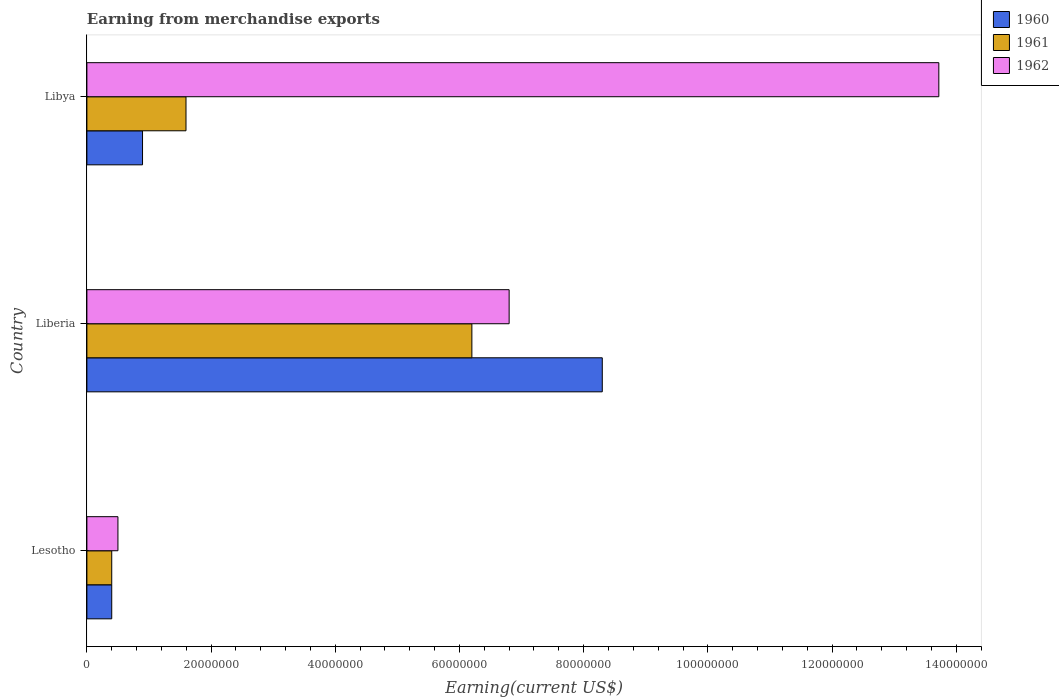How many different coloured bars are there?
Make the answer very short. 3. How many groups of bars are there?
Provide a succinct answer. 3. Are the number of bars per tick equal to the number of legend labels?
Give a very brief answer. Yes. How many bars are there on the 2nd tick from the bottom?
Keep it short and to the point. 3. What is the label of the 1st group of bars from the top?
Provide a short and direct response. Libya. In how many cases, is the number of bars for a given country not equal to the number of legend labels?
Give a very brief answer. 0. What is the amount earned from merchandise exports in 1962 in Libya?
Provide a short and direct response. 1.37e+08. Across all countries, what is the maximum amount earned from merchandise exports in 1961?
Provide a short and direct response. 6.20e+07. In which country was the amount earned from merchandise exports in 1961 maximum?
Make the answer very short. Liberia. In which country was the amount earned from merchandise exports in 1962 minimum?
Provide a succinct answer. Lesotho. What is the total amount earned from merchandise exports in 1961 in the graph?
Keep it short and to the point. 8.20e+07. What is the difference between the amount earned from merchandise exports in 1960 in Lesotho and that in Liberia?
Ensure brevity in your answer.  -7.90e+07. What is the difference between the amount earned from merchandise exports in 1960 in Liberia and the amount earned from merchandise exports in 1962 in Libya?
Give a very brief answer. -5.42e+07. What is the average amount earned from merchandise exports in 1962 per country?
Your response must be concise. 7.01e+07. What is the difference between the amount earned from merchandise exports in 1962 and amount earned from merchandise exports in 1960 in Libya?
Your answer should be compact. 1.28e+08. In how many countries, is the amount earned from merchandise exports in 1960 greater than 24000000 US$?
Your answer should be very brief. 1. What is the ratio of the amount earned from merchandise exports in 1962 in Lesotho to that in Libya?
Make the answer very short. 0.04. What is the difference between the highest and the second highest amount earned from merchandise exports in 1960?
Ensure brevity in your answer.  7.40e+07. What is the difference between the highest and the lowest amount earned from merchandise exports in 1962?
Your answer should be very brief. 1.32e+08. In how many countries, is the amount earned from merchandise exports in 1962 greater than the average amount earned from merchandise exports in 1962 taken over all countries?
Your answer should be very brief. 1. Is the sum of the amount earned from merchandise exports in 1961 in Lesotho and Libya greater than the maximum amount earned from merchandise exports in 1960 across all countries?
Your response must be concise. No. Are all the bars in the graph horizontal?
Offer a very short reply. Yes. Does the graph contain any zero values?
Ensure brevity in your answer.  No. Where does the legend appear in the graph?
Your answer should be very brief. Top right. How many legend labels are there?
Offer a very short reply. 3. How are the legend labels stacked?
Make the answer very short. Vertical. What is the title of the graph?
Provide a succinct answer. Earning from merchandise exports. Does "1970" appear as one of the legend labels in the graph?
Offer a terse response. No. What is the label or title of the X-axis?
Offer a very short reply. Earning(current US$). What is the label or title of the Y-axis?
Give a very brief answer. Country. What is the Earning(current US$) in 1961 in Lesotho?
Offer a terse response. 4.00e+06. What is the Earning(current US$) of 1962 in Lesotho?
Your answer should be very brief. 5.00e+06. What is the Earning(current US$) of 1960 in Liberia?
Provide a short and direct response. 8.30e+07. What is the Earning(current US$) of 1961 in Liberia?
Give a very brief answer. 6.20e+07. What is the Earning(current US$) in 1962 in Liberia?
Offer a terse response. 6.80e+07. What is the Earning(current US$) of 1960 in Libya?
Make the answer very short. 8.96e+06. What is the Earning(current US$) in 1961 in Libya?
Offer a terse response. 1.60e+07. What is the Earning(current US$) of 1962 in Libya?
Provide a short and direct response. 1.37e+08. Across all countries, what is the maximum Earning(current US$) of 1960?
Your answer should be compact. 8.30e+07. Across all countries, what is the maximum Earning(current US$) in 1961?
Offer a terse response. 6.20e+07. Across all countries, what is the maximum Earning(current US$) of 1962?
Provide a succinct answer. 1.37e+08. What is the total Earning(current US$) of 1960 in the graph?
Keep it short and to the point. 9.60e+07. What is the total Earning(current US$) in 1961 in the graph?
Make the answer very short. 8.20e+07. What is the total Earning(current US$) of 1962 in the graph?
Your answer should be compact. 2.10e+08. What is the difference between the Earning(current US$) in 1960 in Lesotho and that in Liberia?
Ensure brevity in your answer.  -7.90e+07. What is the difference between the Earning(current US$) of 1961 in Lesotho and that in Liberia?
Your answer should be compact. -5.80e+07. What is the difference between the Earning(current US$) of 1962 in Lesotho and that in Liberia?
Provide a succinct answer. -6.30e+07. What is the difference between the Earning(current US$) of 1960 in Lesotho and that in Libya?
Your answer should be compact. -4.96e+06. What is the difference between the Earning(current US$) in 1961 in Lesotho and that in Libya?
Give a very brief answer. -1.20e+07. What is the difference between the Earning(current US$) of 1962 in Lesotho and that in Libya?
Give a very brief answer. -1.32e+08. What is the difference between the Earning(current US$) of 1960 in Liberia and that in Libya?
Your answer should be very brief. 7.40e+07. What is the difference between the Earning(current US$) in 1961 in Liberia and that in Libya?
Provide a succinct answer. 4.60e+07. What is the difference between the Earning(current US$) in 1962 in Liberia and that in Libya?
Your answer should be compact. -6.92e+07. What is the difference between the Earning(current US$) of 1960 in Lesotho and the Earning(current US$) of 1961 in Liberia?
Offer a terse response. -5.80e+07. What is the difference between the Earning(current US$) of 1960 in Lesotho and the Earning(current US$) of 1962 in Liberia?
Offer a terse response. -6.40e+07. What is the difference between the Earning(current US$) in 1961 in Lesotho and the Earning(current US$) in 1962 in Liberia?
Provide a succinct answer. -6.40e+07. What is the difference between the Earning(current US$) in 1960 in Lesotho and the Earning(current US$) in 1961 in Libya?
Your response must be concise. -1.20e+07. What is the difference between the Earning(current US$) of 1960 in Lesotho and the Earning(current US$) of 1962 in Libya?
Ensure brevity in your answer.  -1.33e+08. What is the difference between the Earning(current US$) in 1961 in Lesotho and the Earning(current US$) in 1962 in Libya?
Your answer should be very brief. -1.33e+08. What is the difference between the Earning(current US$) in 1960 in Liberia and the Earning(current US$) in 1961 in Libya?
Provide a succinct answer. 6.70e+07. What is the difference between the Earning(current US$) of 1960 in Liberia and the Earning(current US$) of 1962 in Libya?
Keep it short and to the point. -5.42e+07. What is the difference between the Earning(current US$) of 1961 in Liberia and the Earning(current US$) of 1962 in Libya?
Make the answer very short. -7.52e+07. What is the average Earning(current US$) of 1960 per country?
Your answer should be compact. 3.20e+07. What is the average Earning(current US$) of 1961 per country?
Offer a terse response. 2.73e+07. What is the average Earning(current US$) in 1962 per country?
Make the answer very short. 7.01e+07. What is the difference between the Earning(current US$) in 1960 and Earning(current US$) in 1962 in Lesotho?
Ensure brevity in your answer.  -1.00e+06. What is the difference between the Earning(current US$) of 1961 and Earning(current US$) of 1962 in Lesotho?
Your response must be concise. -1.00e+06. What is the difference between the Earning(current US$) in 1960 and Earning(current US$) in 1961 in Liberia?
Make the answer very short. 2.10e+07. What is the difference between the Earning(current US$) in 1960 and Earning(current US$) in 1962 in Liberia?
Give a very brief answer. 1.50e+07. What is the difference between the Earning(current US$) in 1961 and Earning(current US$) in 1962 in Liberia?
Offer a very short reply. -6.00e+06. What is the difference between the Earning(current US$) in 1960 and Earning(current US$) in 1961 in Libya?
Offer a very short reply. -7.00e+06. What is the difference between the Earning(current US$) in 1960 and Earning(current US$) in 1962 in Libya?
Ensure brevity in your answer.  -1.28e+08. What is the difference between the Earning(current US$) in 1961 and Earning(current US$) in 1962 in Libya?
Offer a terse response. -1.21e+08. What is the ratio of the Earning(current US$) of 1960 in Lesotho to that in Liberia?
Offer a very short reply. 0.05. What is the ratio of the Earning(current US$) in 1961 in Lesotho to that in Liberia?
Ensure brevity in your answer.  0.06. What is the ratio of the Earning(current US$) of 1962 in Lesotho to that in Liberia?
Your answer should be compact. 0.07. What is the ratio of the Earning(current US$) in 1960 in Lesotho to that in Libya?
Offer a terse response. 0.45. What is the ratio of the Earning(current US$) of 1961 in Lesotho to that in Libya?
Keep it short and to the point. 0.25. What is the ratio of the Earning(current US$) in 1962 in Lesotho to that in Libya?
Provide a succinct answer. 0.04. What is the ratio of the Earning(current US$) of 1960 in Liberia to that in Libya?
Ensure brevity in your answer.  9.26. What is the ratio of the Earning(current US$) in 1961 in Liberia to that in Libya?
Make the answer very short. 3.88. What is the ratio of the Earning(current US$) of 1962 in Liberia to that in Libya?
Your answer should be very brief. 0.5. What is the difference between the highest and the second highest Earning(current US$) in 1960?
Ensure brevity in your answer.  7.40e+07. What is the difference between the highest and the second highest Earning(current US$) of 1961?
Give a very brief answer. 4.60e+07. What is the difference between the highest and the second highest Earning(current US$) in 1962?
Provide a succinct answer. 6.92e+07. What is the difference between the highest and the lowest Earning(current US$) of 1960?
Your answer should be compact. 7.90e+07. What is the difference between the highest and the lowest Earning(current US$) of 1961?
Offer a very short reply. 5.80e+07. What is the difference between the highest and the lowest Earning(current US$) in 1962?
Your response must be concise. 1.32e+08. 